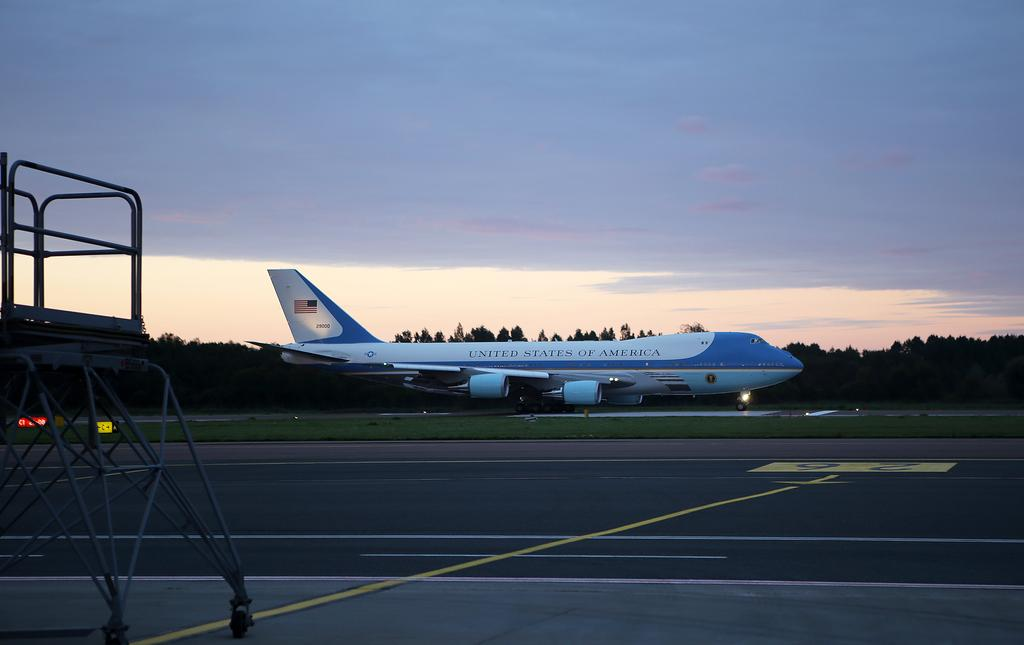What type of surface can be seen in the image? There is a road in the image. What structure is present in the image? There is a stand in the image. What type of vegetation is visible in the image? There is grass in the image. What mode of transportation can be seen in the image? There is an airplane in the image. What other natural elements are present in the image? There are trees in the image. What else can be seen in the image besides the mentioned elements? There are some objects in the image. What is visible in the background of the image? The sky is visible in the background of the image. What type of behavior does the lawyer exhibit in the image? There is no lawyer present in the image, so it is not possible to determine their behavior. 